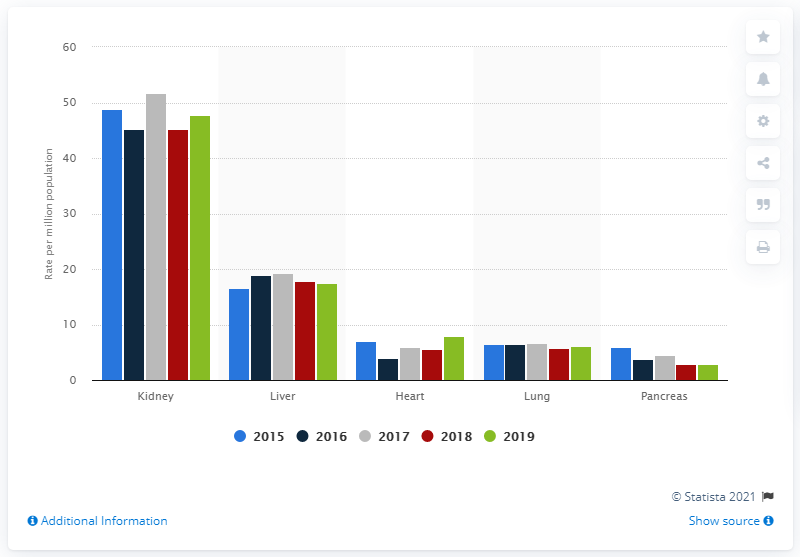Outline some significant characteristics in this image. In 2019, the rate of kidney transplantation activity was 47.8%. 